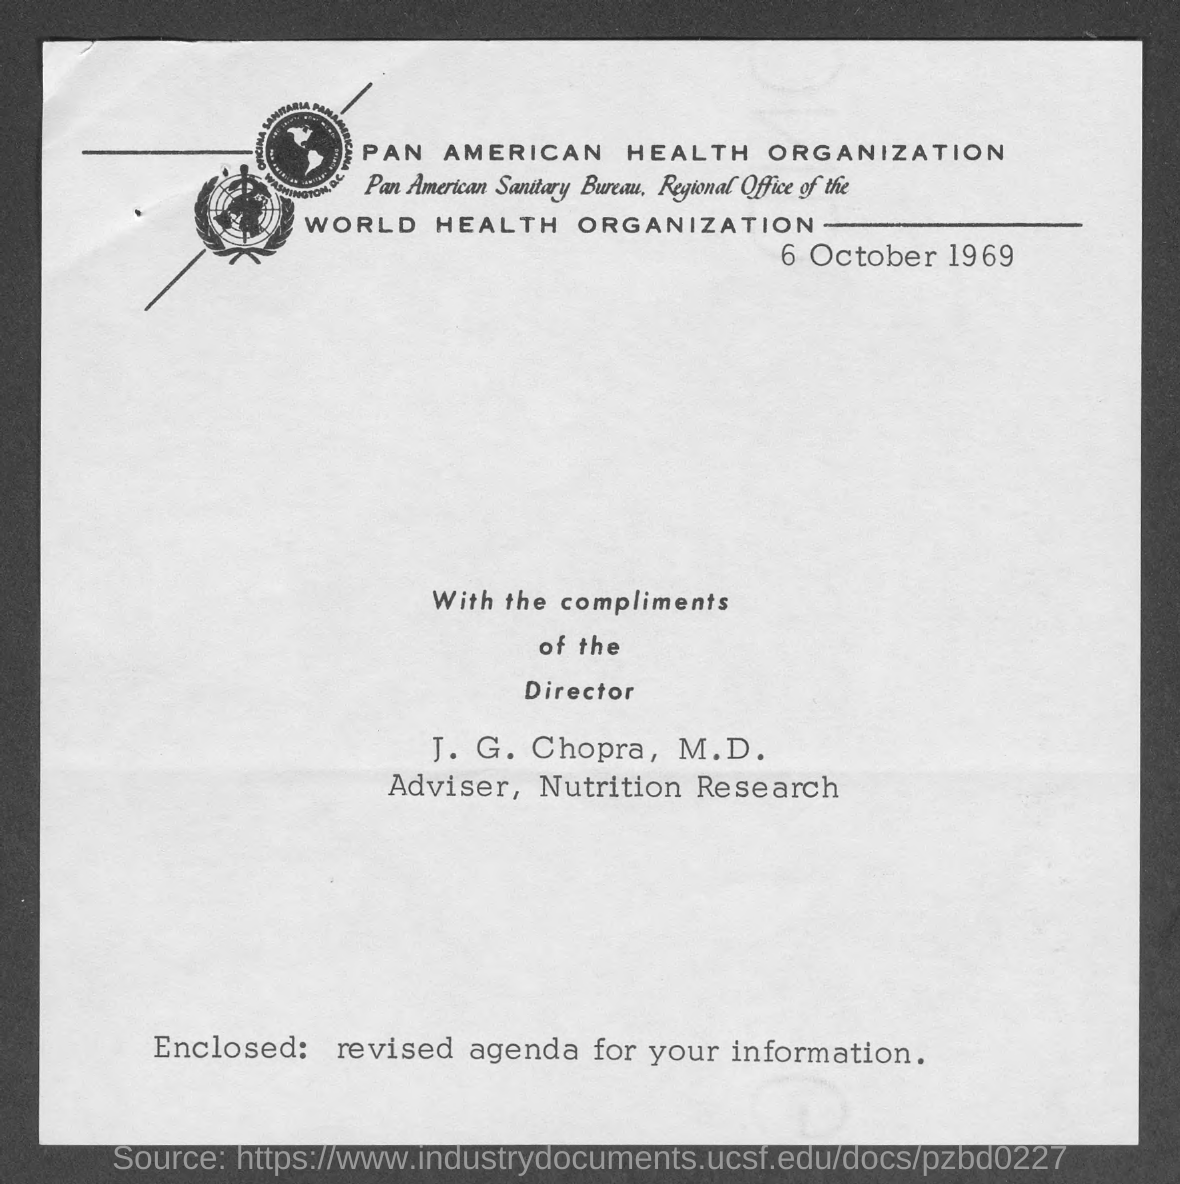What is the date mentioned in this document?
Provide a succinct answer. 6 October 1969. Who is the Adviser, Nutrition Research?
Provide a succinct answer. J. G. Chopra, M.D. 